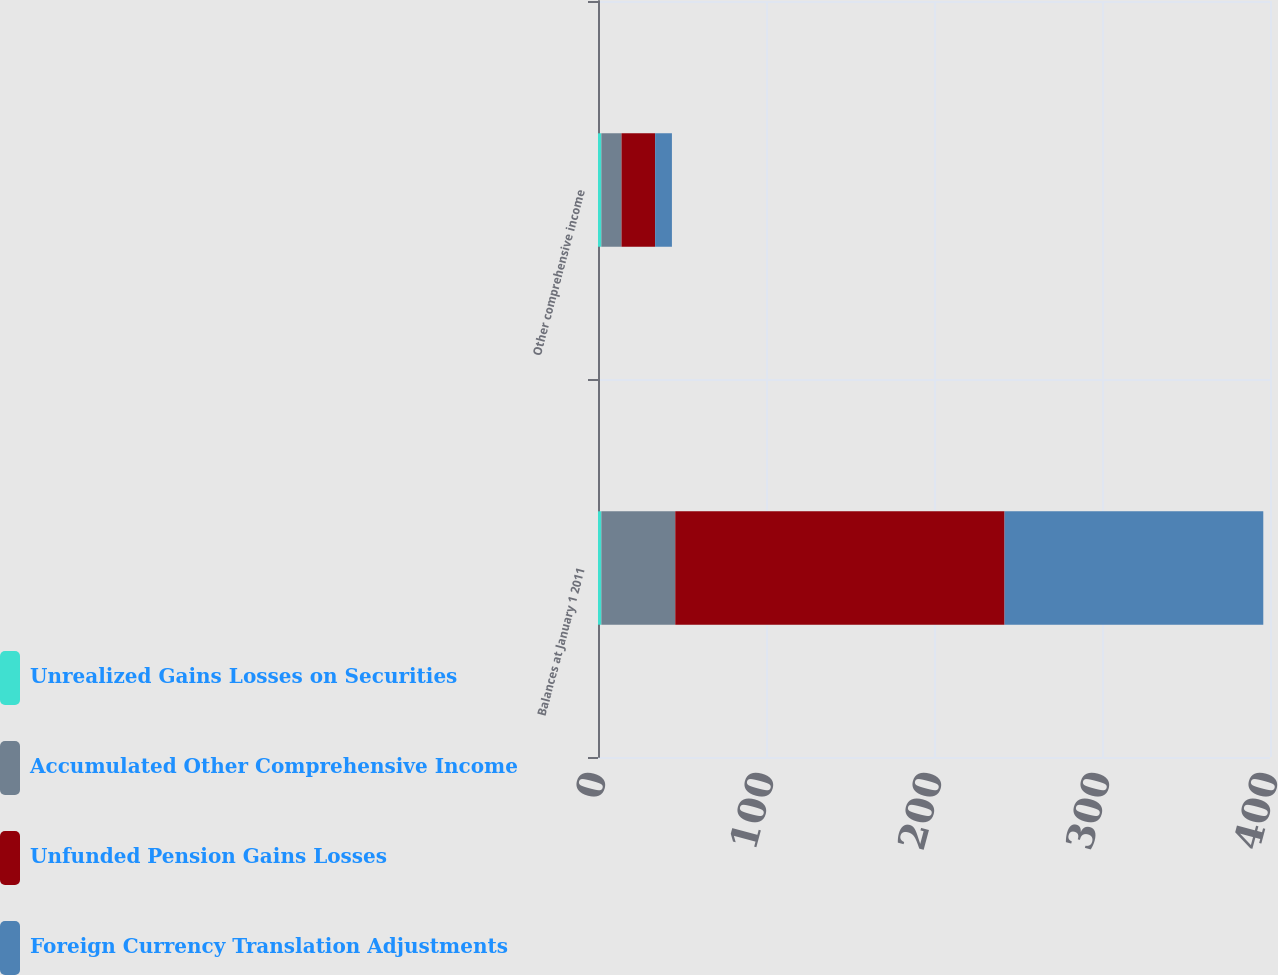<chart> <loc_0><loc_0><loc_500><loc_500><stacked_bar_chart><ecel><fcel>Balances at January 1 2011<fcel>Other comprehensive income<nl><fcel>Unrealized Gains Losses on Securities<fcel>2<fcel>2<nl><fcel>Accumulated Other Comprehensive Income<fcel>44<fcel>12<nl><fcel>Unfunded Pension Gains Losses<fcel>196<fcel>20<nl><fcel>Foreign Currency Translation Adjustments<fcel>154<fcel>10<nl></chart> 